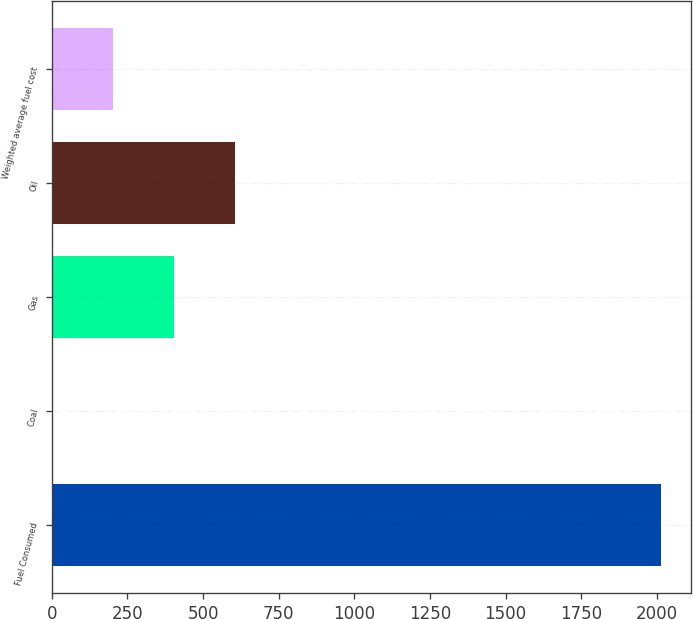<chart> <loc_0><loc_0><loc_500><loc_500><bar_chart><fcel>Fuel Consumed<fcel>Coal<fcel>Gas<fcel>Oil<fcel>Weighted average fuel cost<nl><fcel>2012<fcel>2.98<fcel>404.78<fcel>605.68<fcel>203.88<nl></chart> 